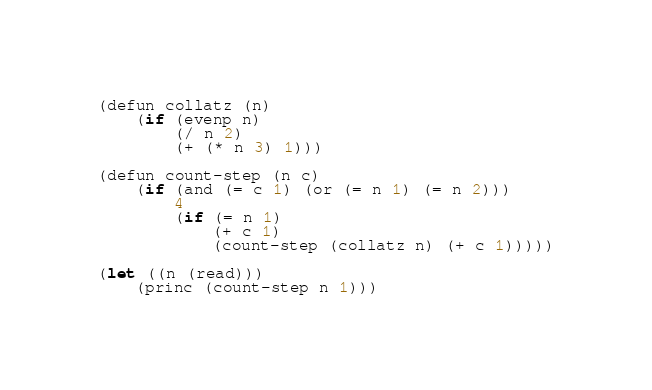<code> <loc_0><loc_0><loc_500><loc_500><_Lisp_>(defun collatz (n)
    (if (evenp n)
        (/ n 2)
        (+ (* n 3) 1)))

(defun count-step (n c)
    (if (and (= c 1) (or (= n 1) (= n 2)))
        4
        (if (= n 1)
            (+ c 1)
            (count-step (collatz n) (+ c 1)))))

(let ((n (read)))
    (princ (count-step n 1)))
</code> 